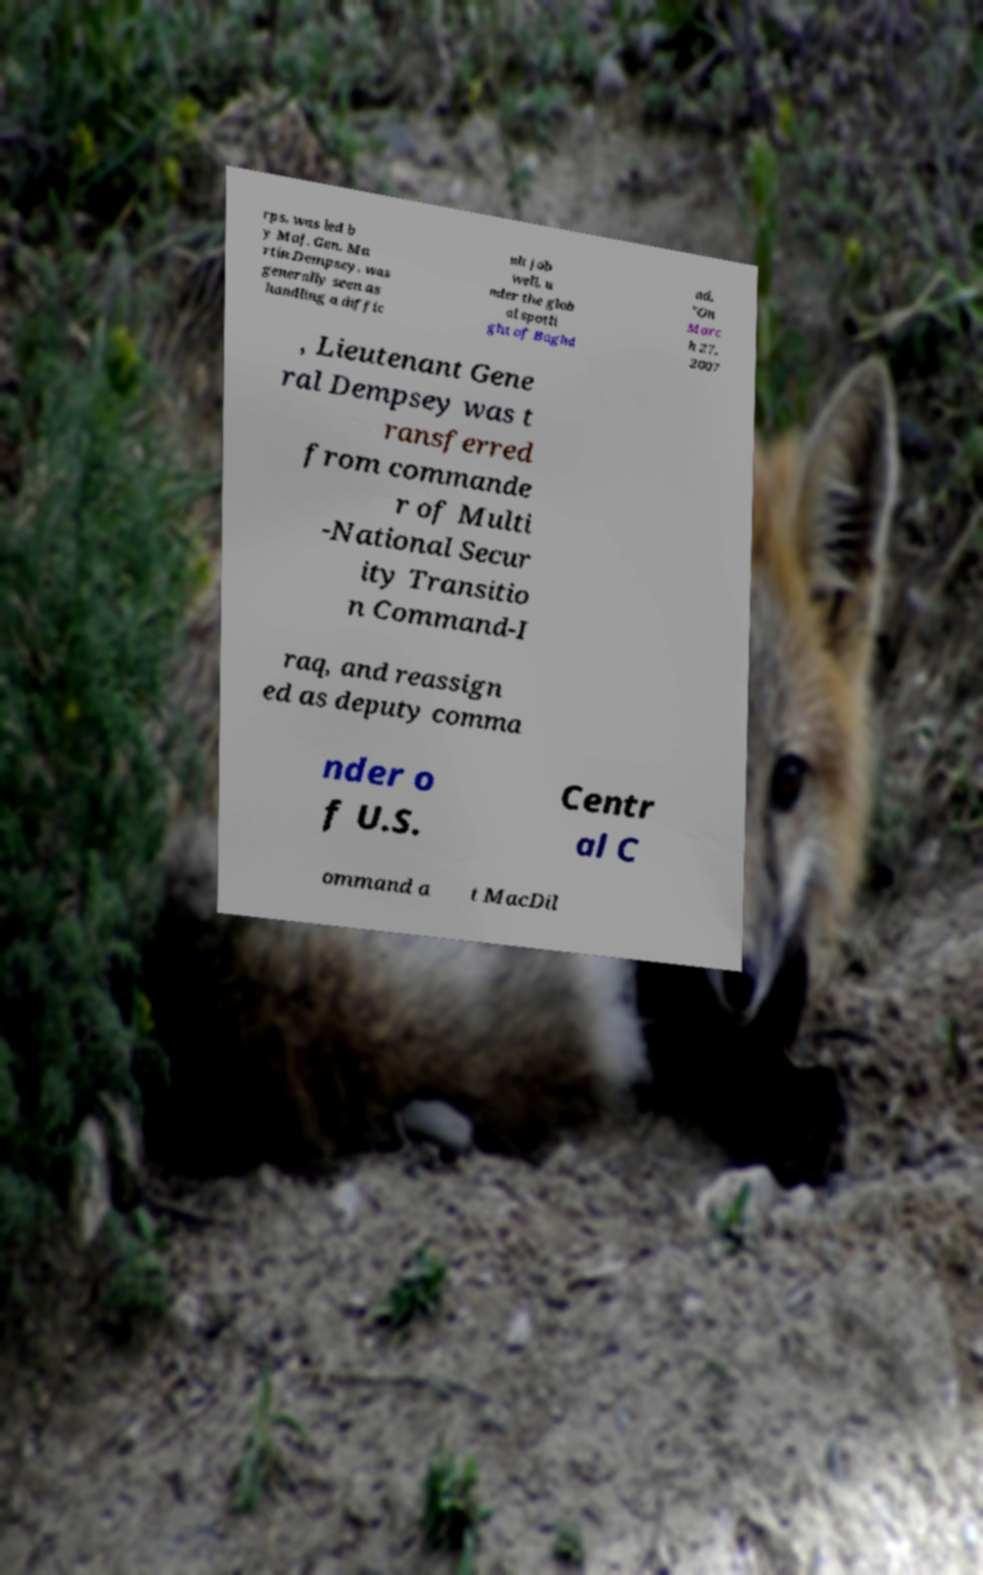I need the written content from this picture converted into text. Can you do that? rps, was led b y Maj. Gen. Ma rtin Dempsey, was generally seen as handling a diffic ult job well, u nder the glob al spotli ght of Baghd ad. "On Marc h 27, 2007 , Lieutenant Gene ral Dempsey was t ransferred from commande r of Multi -National Secur ity Transitio n Command-I raq, and reassign ed as deputy comma nder o f U.S. Centr al C ommand a t MacDil 